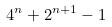<formula> <loc_0><loc_0><loc_500><loc_500>4 ^ { n } + 2 ^ { n + 1 } - 1</formula> 